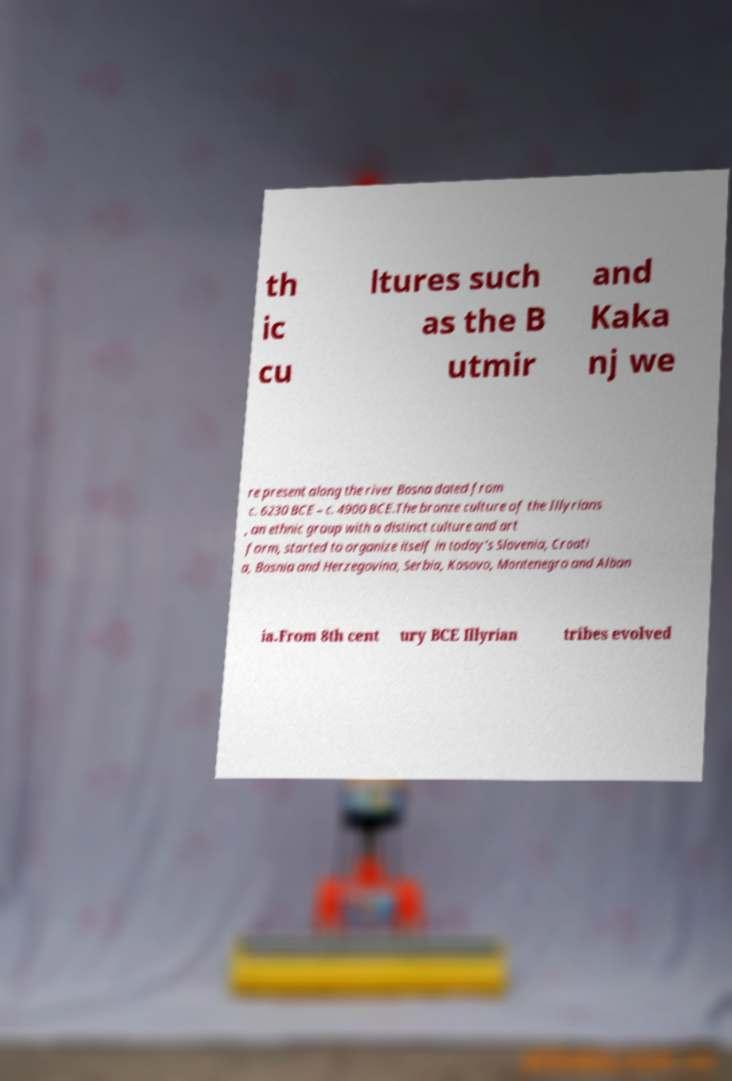Please read and relay the text visible in this image. What does it say? th ic cu ltures such as the B utmir and Kaka nj we re present along the river Bosna dated from c. 6230 BCE – c. 4900 BCE.The bronze culture of the Illyrians , an ethnic group with a distinct culture and art form, started to organize itself in today's Slovenia, Croati a, Bosnia and Herzegovina, Serbia, Kosovo, Montenegro and Alban ia.From 8th cent ury BCE Illyrian tribes evolved 